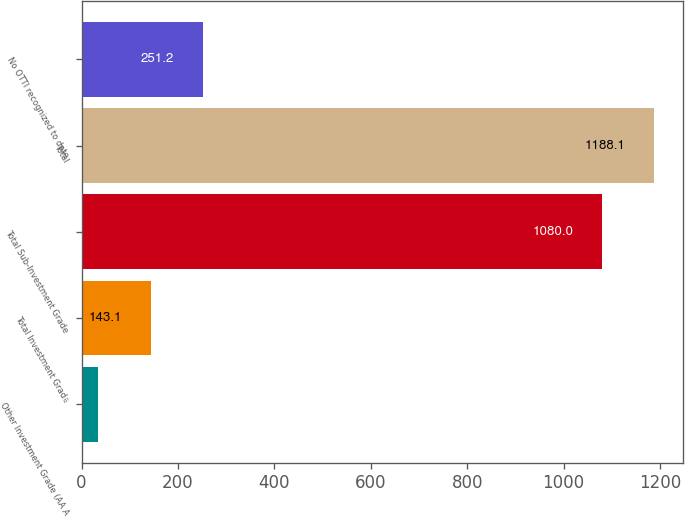<chart> <loc_0><loc_0><loc_500><loc_500><bar_chart><fcel>Other Investment Grade (AA A<fcel>Total Investment Grade<fcel>Total Sub-Investment Grade<fcel>Total<fcel>No OTTI recognized to date<nl><fcel>35<fcel>143.1<fcel>1080<fcel>1188.1<fcel>251.2<nl></chart> 